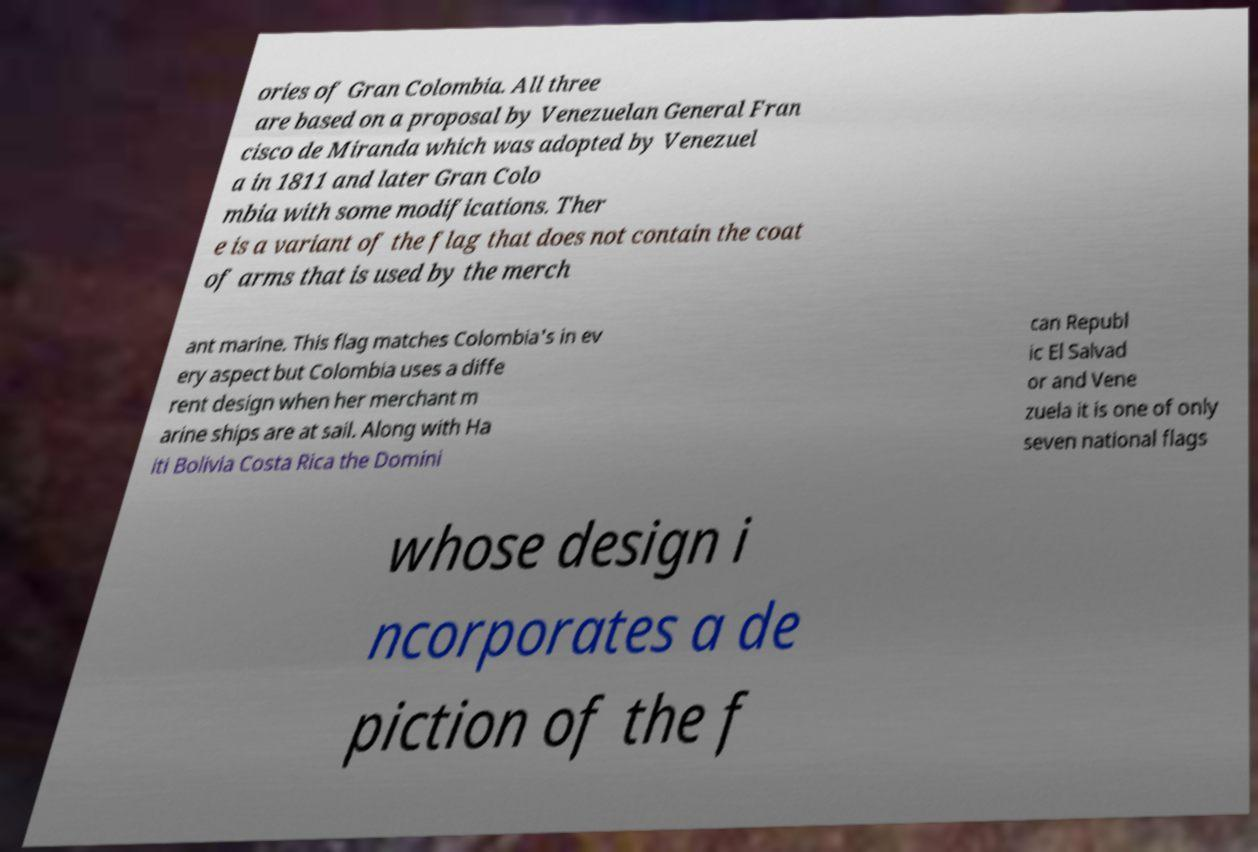Could you extract and type out the text from this image? ories of Gran Colombia. All three are based on a proposal by Venezuelan General Fran cisco de Miranda which was adopted by Venezuel a in 1811 and later Gran Colo mbia with some modifications. Ther e is a variant of the flag that does not contain the coat of arms that is used by the merch ant marine. This flag matches Colombia's in ev ery aspect but Colombia uses a diffe rent design when her merchant m arine ships are at sail. Along with Ha iti Bolivia Costa Rica the Domini can Republ ic El Salvad or and Vene zuela it is one of only seven national flags whose design i ncorporates a de piction of the f 